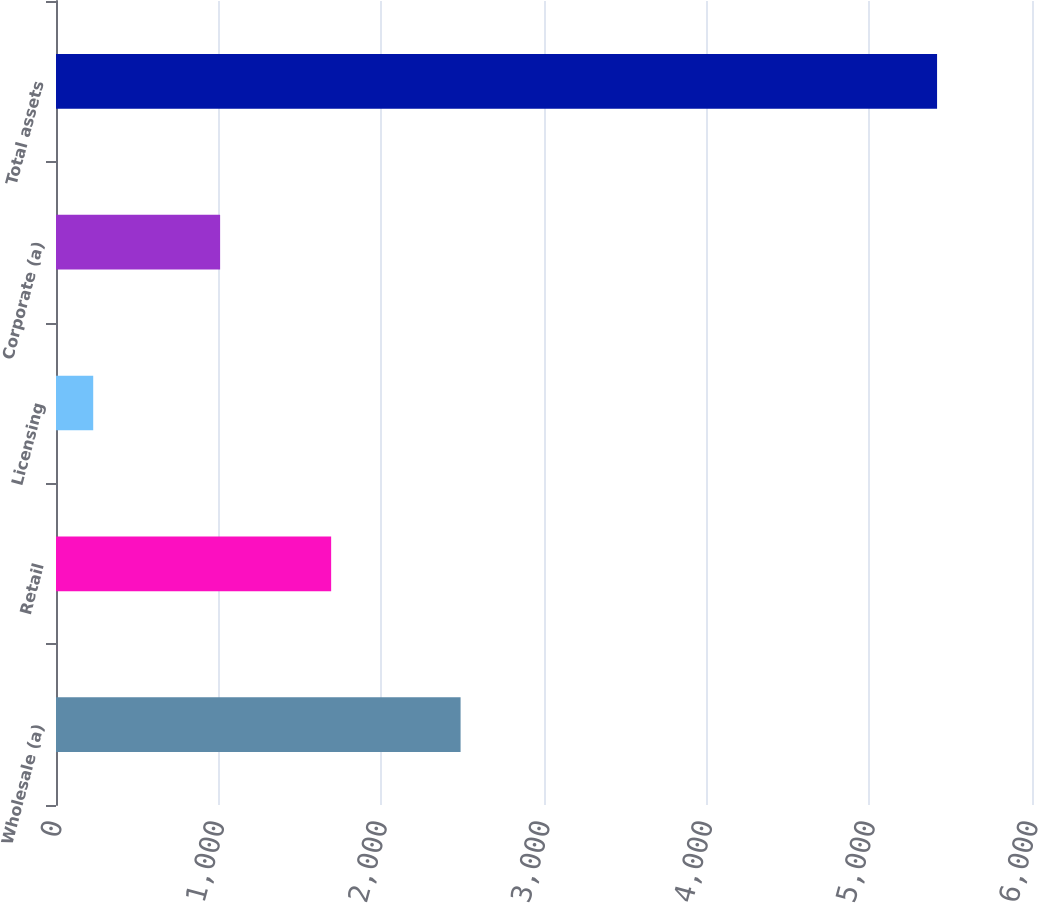Convert chart. <chart><loc_0><loc_0><loc_500><loc_500><bar_chart><fcel>Wholesale (a)<fcel>Retail<fcel>Licensing<fcel>Corporate (a)<fcel>Total assets<nl><fcel>2487.2<fcel>1691.5<fcel>228.8<fcel>1008.9<fcel>5416.4<nl></chart> 